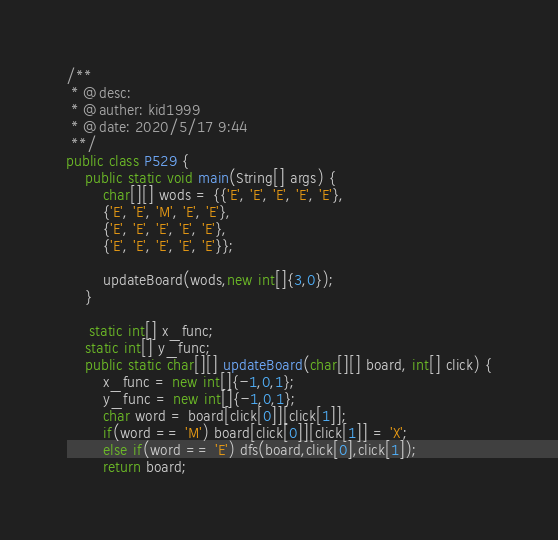<code> <loc_0><loc_0><loc_500><loc_500><_Java_>/**
 * @desc:
 * @auther: kid1999
 * @date: 2020/5/17 9:44
 **/
public class P529 {
    public static void main(String[] args) {
        char[][] wods = {{'E', 'E', 'E', 'E', 'E'},
        {'E', 'E', 'M', 'E', 'E'},
        {'E', 'E', 'E', 'E', 'E'},
        {'E', 'E', 'E', 'E', 'E'}};

        updateBoard(wods,new int[]{3,0});
    }

     static int[] x_func;
    static int[] y_func;
    public static char[][] updateBoard(char[][] board, int[] click) {
        x_func = new int[]{-1,0,1};
        y_func = new int[]{-1,0,1};
        char word = board[click[0]][click[1]];
        if(word == 'M') board[click[0]][click[1]] = 'X';
        else if(word == 'E') dfs(board,click[0],click[1]);
        return board;</code> 